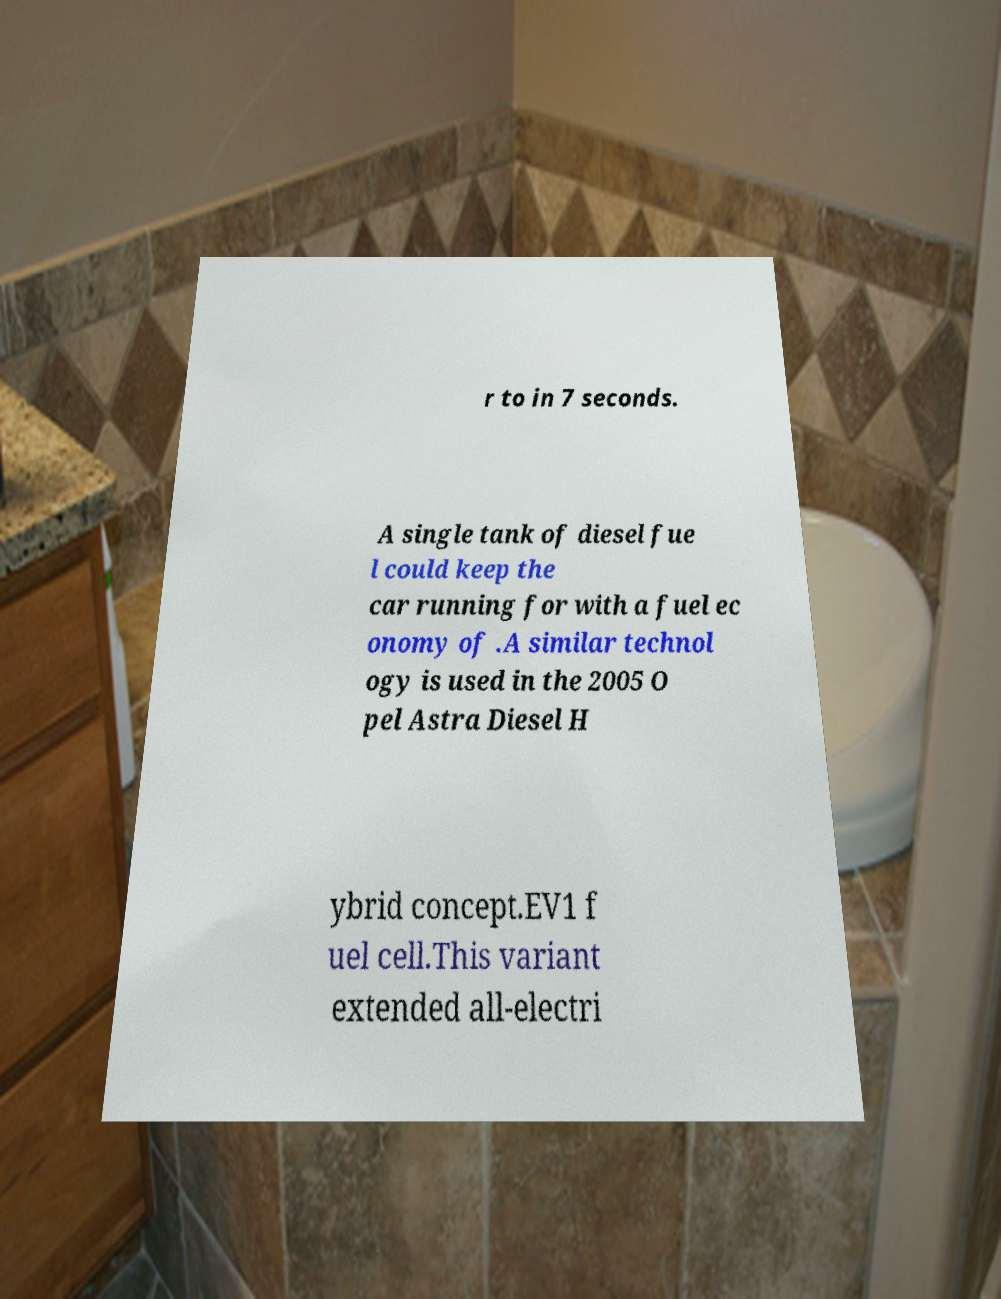Please read and relay the text visible in this image. What does it say? r to in 7 seconds. A single tank of diesel fue l could keep the car running for with a fuel ec onomy of .A similar technol ogy is used in the 2005 O pel Astra Diesel H ybrid concept.EV1 f uel cell.This variant extended all-electri 